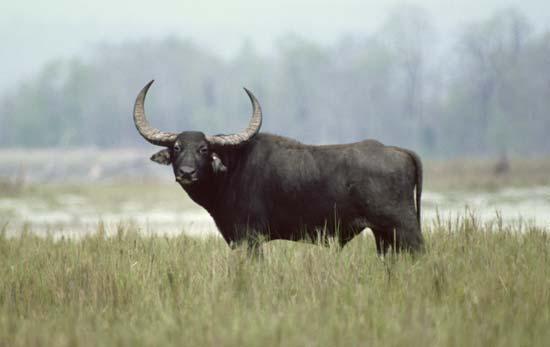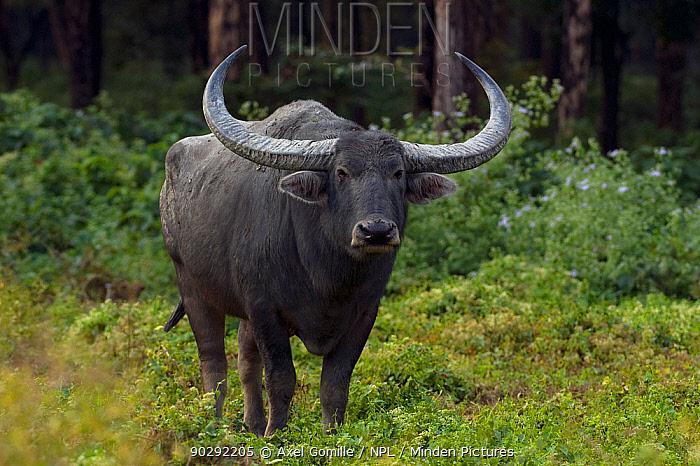The first image is the image on the left, the second image is the image on the right. Analyze the images presented: Is the assertion "Is one of the image there is a water buffalo standing in the water." valid? Answer yes or no. No. The first image is the image on the left, the second image is the image on the right. Considering the images on both sides, is "There is a single black buffalo with horns over a foot long facing left in a field of grass." valid? Answer yes or no. Yes. 